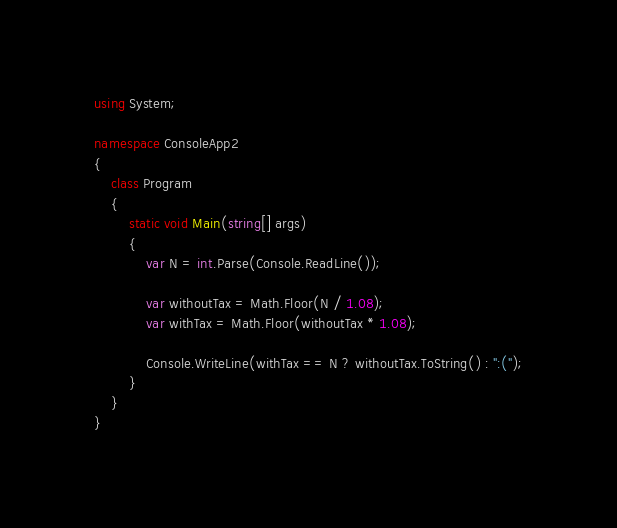Convert code to text. <code><loc_0><loc_0><loc_500><loc_500><_C#_>using System;

namespace ConsoleApp2
{
    class Program
    {
        static void Main(string[] args)
        {
            var N = int.Parse(Console.ReadLine());

            var withoutTax = Math.Floor(N / 1.08);
            var withTax = Math.Floor(withoutTax * 1.08);

            Console.WriteLine(withTax == N ? withoutTax.ToString() : ":(");
        }
    }
}</code> 